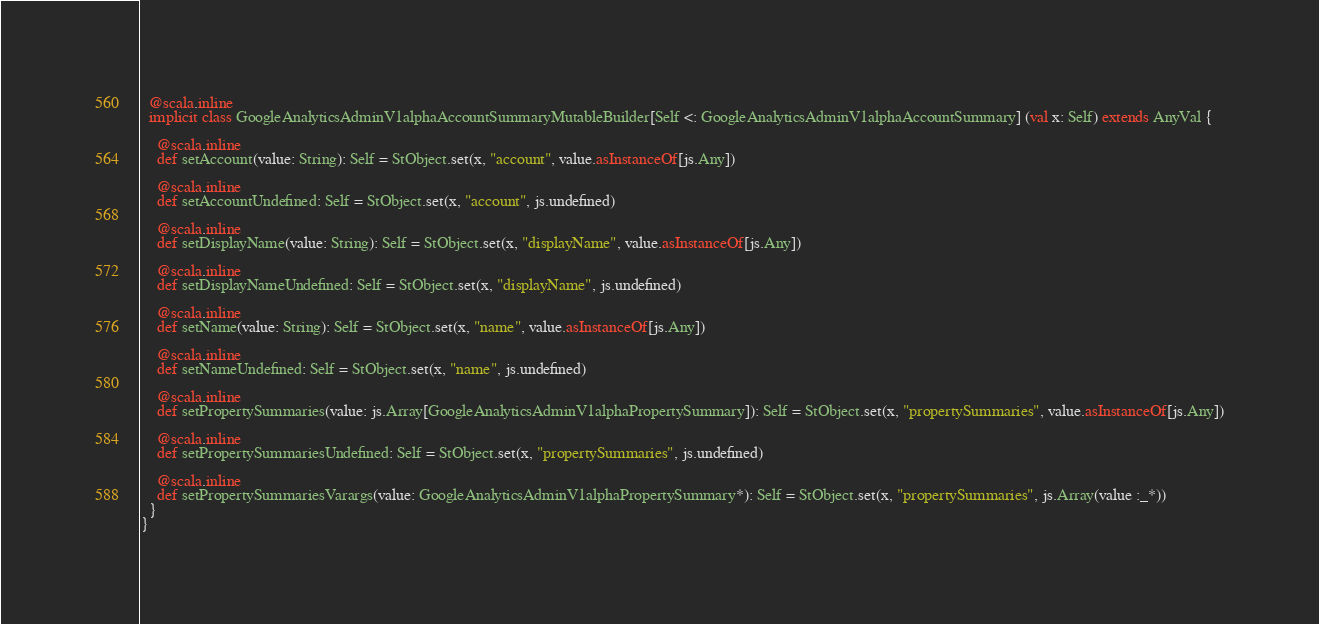Convert code to text. <code><loc_0><loc_0><loc_500><loc_500><_Scala_>  @scala.inline
  implicit class GoogleAnalyticsAdminV1alphaAccountSummaryMutableBuilder[Self <: GoogleAnalyticsAdminV1alphaAccountSummary] (val x: Self) extends AnyVal {
    
    @scala.inline
    def setAccount(value: String): Self = StObject.set(x, "account", value.asInstanceOf[js.Any])
    
    @scala.inline
    def setAccountUndefined: Self = StObject.set(x, "account", js.undefined)
    
    @scala.inline
    def setDisplayName(value: String): Self = StObject.set(x, "displayName", value.asInstanceOf[js.Any])
    
    @scala.inline
    def setDisplayNameUndefined: Self = StObject.set(x, "displayName", js.undefined)
    
    @scala.inline
    def setName(value: String): Self = StObject.set(x, "name", value.asInstanceOf[js.Any])
    
    @scala.inline
    def setNameUndefined: Self = StObject.set(x, "name", js.undefined)
    
    @scala.inline
    def setPropertySummaries(value: js.Array[GoogleAnalyticsAdminV1alphaPropertySummary]): Self = StObject.set(x, "propertySummaries", value.asInstanceOf[js.Any])
    
    @scala.inline
    def setPropertySummariesUndefined: Self = StObject.set(x, "propertySummaries", js.undefined)
    
    @scala.inline
    def setPropertySummariesVarargs(value: GoogleAnalyticsAdminV1alphaPropertySummary*): Self = StObject.set(x, "propertySummaries", js.Array(value :_*))
  }
}
</code> 